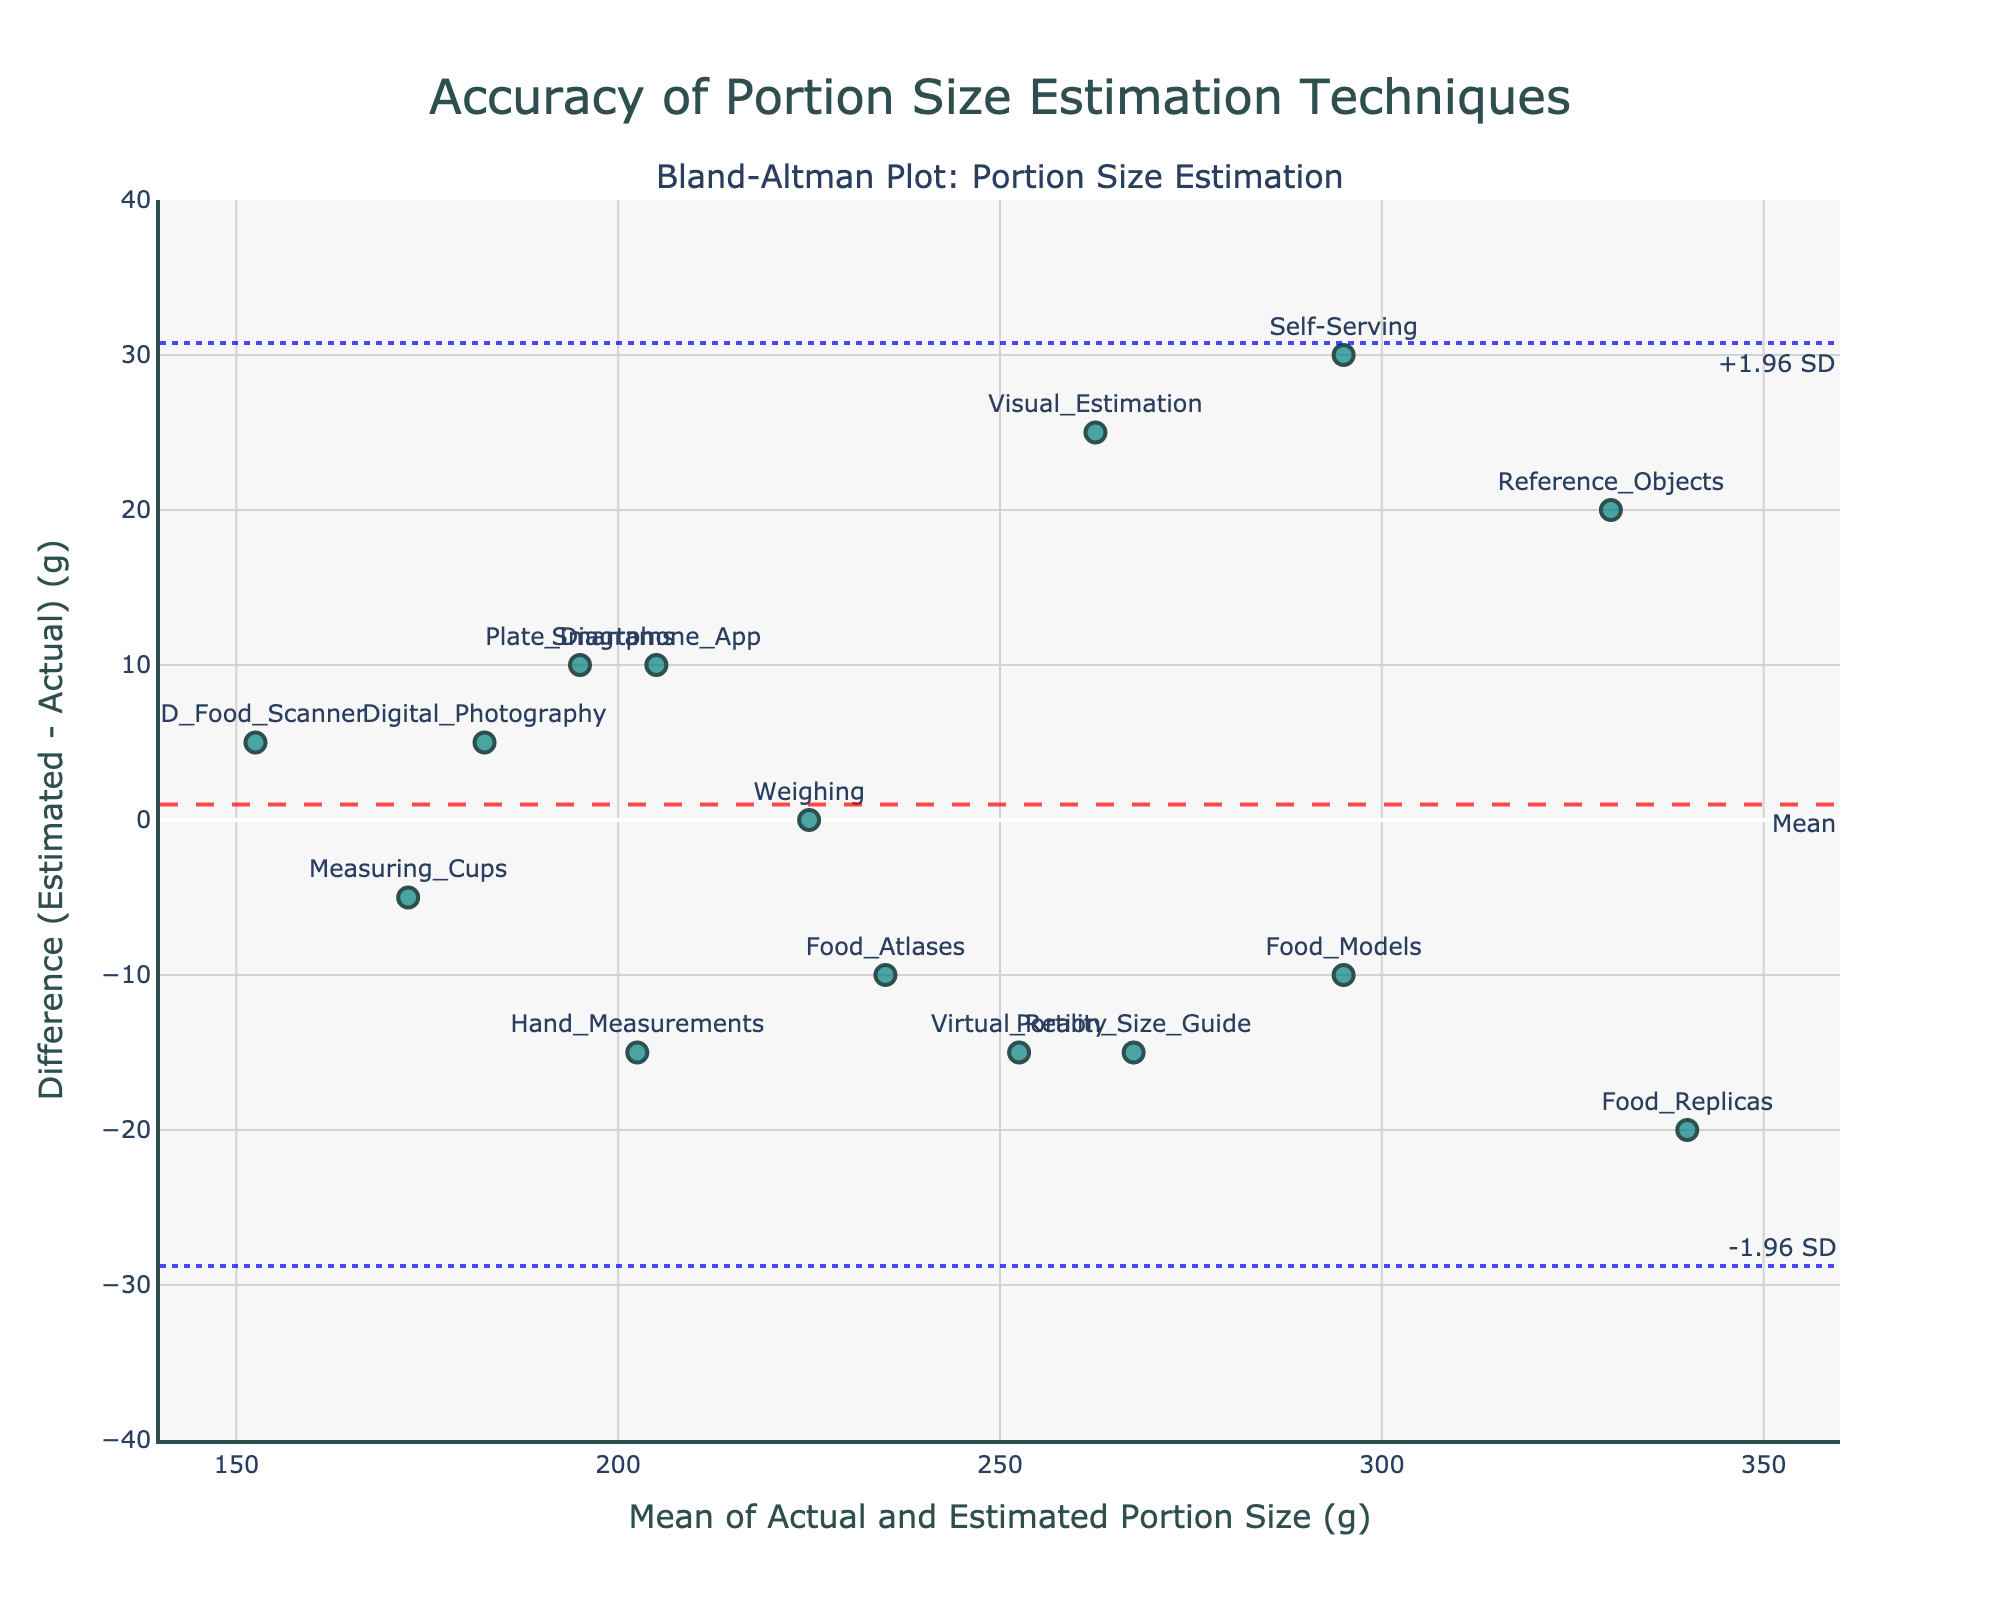What's the title of the plot? The title of the plot is written at the top center of the figure. It reads "Accuracy of Portion Size Estimation Techniques".
Answer: Accuracy of Portion Size Estimation Techniques What are the x-axis and y-axis titles in the plot? The x-axis title reads "Mean of Actual and Estimated Portion Size (g)" and the y-axis title reads "Difference (Estimated - Actual) (g)".
Answer: Mean of Actual and Estimated Portion Size (g); Difference (Estimated - Actual) (g) How many methods are represented in the plot? By counting the data points (markers) in the plot, each labeled with a unique method, we find there are 15 methods.
Answer: 15 What does the horizontal dashed red line represent? The horizontal dashed red line corresponds to the mean difference between the estimated and actual portion sizes. The annotation text next to the line indicates it represents the mean value.
Answer: Mean difference Which method has the largest positive difference between estimated and actual portion size? Observing the vertical positions of the data points, the method "Self-Serving" has the largest positive difference, as it is located the highest above the zero line on the y-axis.
Answer: Self-Serving What are the approximate limits of agreement (LoA) in the plot? The plot contains horizontal dotted blue lines which represent the limits of agreement. These lines are approximately located at y-values of +1.96 SD and -1.96 SD, which can be visually estimated as around 30 and -30, respectively.
Answer: +30 and -30 Which method has the smallest absolute difference between estimated and actual portion size? The method "Weighing" is perfectly aligned with the zero difference line, indicating an absence of any difference between the estimated and actual portion sizes.
Answer: Weighing How does the "Digital Photography" method compare to "Food Atlases" in terms of the accuracy of portion size estimation? Comparing the vertical positions of "Digital Photography" and "Food Atlases", "Digital Photography" has a smaller positive difference compared to "Food Atlases", which has a negative difference. This indicates "Digital Photography" is slightly more accurate.
Answer: Digital Photography is more accurate What's the purpose of the Bland–Altman plot in this context? The Bland–Altman plot is used to assess the accuracy and agreement between different portion size estimation techniques by plotting the differences between the estimated and actual portion sizes against their mean.
Answer: Assess accuracy and agreement 